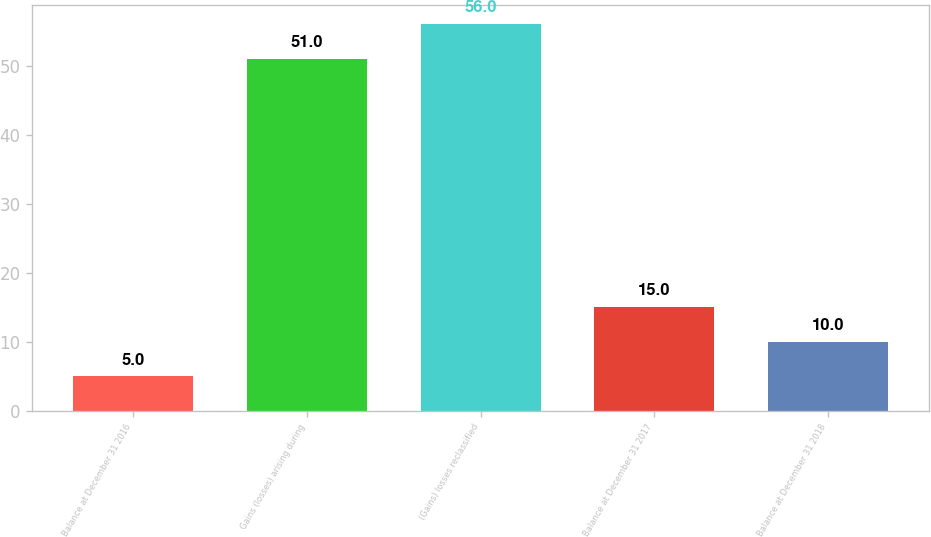<chart> <loc_0><loc_0><loc_500><loc_500><bar_chart><fcel>Balance at December 31 2016<fcel>Gains (losses) arising during<fcel>(Gains) losses reclassified<fcel>Balance at December 31 2017<fcel>Balance at December 31 2018<nl><fcel>5<fcel>51<fcel>56<fcel>15<fcel>10<nl></chart> 